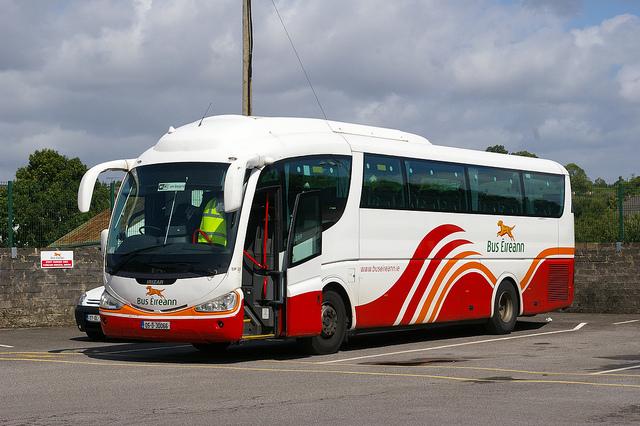What is tyhe color of the buses?
Keep it brief. White and red. What does the front of the bus say?
Concise answer only. Bus eireann. Is the bus in a parking space?
Concise answer only. Yes. Is the bus green color?
Quick response, please. No. 